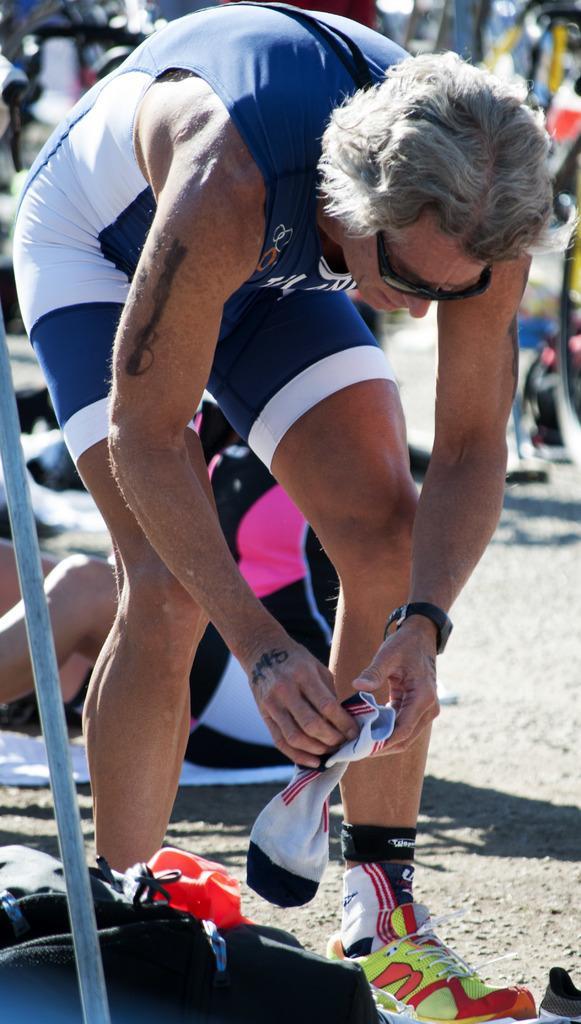In one or two sentences, can you explain what this image depicts? In this picture we can see a person holding socks, behind we can see few people. 